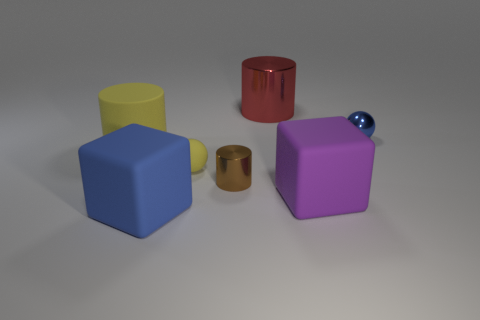Subtract all metallic cylinders. How many cylinders are left? 1 Subtract all blocks. How many objects are left? 5 Add 1 big objects. How many objects exist? 8 Subtract 1 cylinders. How many cylinders are left? 2 Subtract all red cylinders. How many cylinders are left? 2 Subtract 1 blue spheres. How many objects are left? 6 Subtract all cyan cylinders. Subtract all red blocks. How many cylinders are left? 3 Subtract all green cubes. How many red cylinders are left? 1 Subtract all big cylinders. Subtract all large gray cylinders. How many objects are left? 5 Add 3 big red shiny cylinders. How many big red shiny cylinders are left? 4 